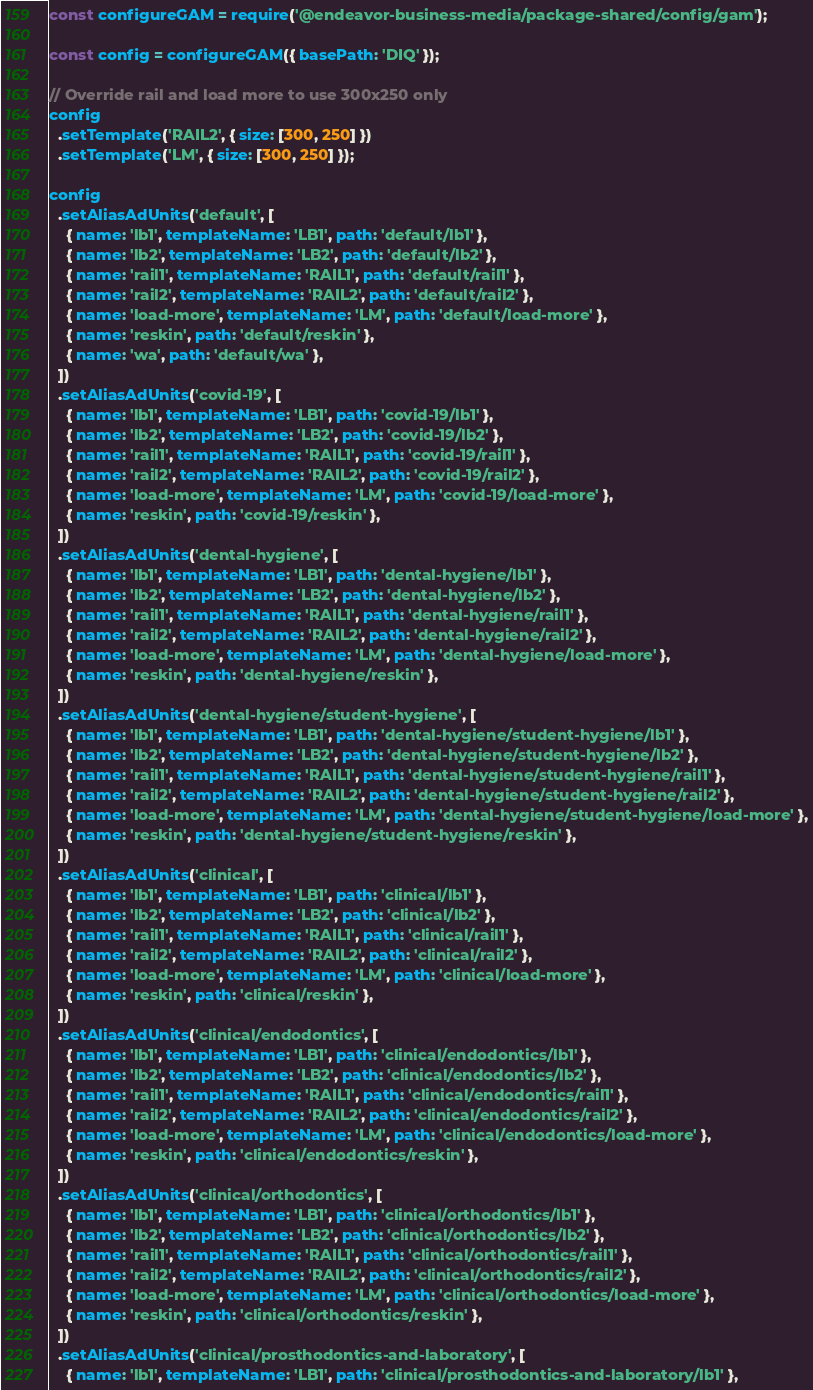<code> <loc_0><loc_0><loc_500><loc_500><_JavaScript_>const configureGAM = require('@endeavor-business-media/package-shared/config/gam');

const config = configureGAM({ basePath: 'DIQ' });

// Override rail and load more to use 300x250 only
config
  .setTemplate('RAIL2', { size: [300, 250] })
  .setTemplate('LM', { size: [300, 250] });

config
  .setAliasAdUnits('default', [
    { name: 'lb1', templateName: 'LB1', path: 'default/lb1' },
    { name: 'lb2', templateName: 'LB2', path: 'default/lb2' },
    { name: 'rail1', templateName: 'RAIL1', path: 'default/rail1' },
    { name: 'rail2', templateName: 'RAIL2', path: 'default/rail2' },
    { name: 'load-more', templateName: 'LM', path: 'default/load-more' },
    { name: 'reskin', path: 'default/reskin' },
    { name: 'wa', path: 'default/wa' },
  ])
  .setAliasAdUnits('covid-19', [
    { name: 'lb1', templateName: 'LB1', path: 'covid-19/lb1' },
    { name: 'lb2', templateName: 'LB2', path: 'covid-19/lb2' },
    { name: 'rail1', templateName: 'RAIL1', path: 'covid-19/rail1' },
    { name: 'rail2', templateName: 'RAIL2', path: 'covid-19/rail2' },
    { name: 'load-more', templateName: 'LM', path: 'covid-19/load-more' },
    { name: 'reskin', path: 'covid-19/reskin' },
  ])
  .setAliasAdUnits('dental-hygiene', [
    { name: 'lb1', templateName: 'LB1', path: 'dental-hygiene/lb1' },
    { name: 'lb2', templateName: 'LB2', path: 'dental-hygiene/lb2' },
    { name: 'rail1', templateName: 'RAIL1', path: 'dental-hygiene/rail1' },
    { name: 'rail2', templateName: 'RAIL2', path: 'dental-hygiene/rail2' },
    { name: 'load-more', templateName: 'LM', path: 'dental-hygiene/load-more' },
    { name: 'reskin', path: 'dental-hygiene/reskin' },
  ])
  .setAliasAdUnits('dental-hygiene/student-hygiene', [
    { name: 'lb1', templateName: 'LB1', path: 'dental-hygiene/student-hygiene/lb1' },
    { name: 'lb2', templateName: 'LB2', path: 'dental-hygiene/student-hygiene/lb2' },
    { name: 'rail1', templateName: 'RAIL1', path: 'dental-hygiene/student-hygiene/rail1' },
    { name: 'rail2', templateName: 'RAIL2', path: 'dental-hygiene/student-hygiene/rail2' },
    { name: 'load-more', templateName: 'LM', path: 'dental-hygiene/student-hygiene/load-more' },
    { name: 'reskin', path: 'dental-hygiene/student-hygiene/reskin' },
  ])
  .setAliasAdUnits('clinical', [
    { name: 'lb1', templateName: 'LB1', path: 'clinical/lb1' },
    { name: 'lb2', templateName: 'LB2', path: 'clinical/lb2' },
    { name: 'rail1', templateName: 'RAIL1', path: 'clinical/rail1' },
    { name: 'rail2', templateName: 'RAIL2', path: 'clinical/rail2' },
    { name: 'load-more', templateName: 'LM', path: 'clinical/load-more' },
    { name: 'reskin', path: 'clinical/reskin' },
  ])
  .setAliasAdUnits('clinical/endodontics', [
    { name: 'lb1', templateName: 'LB1', path: 'clinical/endodontics/lb1' },
    { name: 'lb2', templateName: 'LB2', path: 'clinical/endodontics/lb2' },
    { name: 'rail1', templateName: 'RAIL1', path: 'clinical/endodontics/rail1' },
    { name: 'rail2', templateName: 'RAIL2', path: 'clinical/endodontics/rail2' },
    { name: 'load-more', templateName: 'LM', path: 'clinical/endodontics/load-more' },
    { name: 'reskin', path: 'clinical/endodontics/reskin' },
  ])
  .setAliasAdUnits('clinical/orthodontics', [
    { name: 'lb1', templateName: 'LB1', path: 'clinical/orthodontics/lb1' },
    { name: 'lb2', templateName: 'LB2', path: 'clinical/orthodontics/lb2' },
    { name: 'rail1', templateName: 'RAIL1', path: 'clinical/orthodontics/rail1' },
    { name: 'rail2', templateName: 'RAIL2', path: 'clinical/orthodontics/rail2' },
    { name: 'load-more', templateName: 'LM', path: 'clinical/orthodontics/load-more' },
    { name: 'reskin', path: 'clinical/orthodontics/reskin' },
  ])
  .setAliasAdUnits('clinical/prosthodontics-and-laboratory', [
    { name: 'lb1', templateName: 'LB1', path: 'clinical/prosthodontics-and-laboratory/lb1' },</code> 